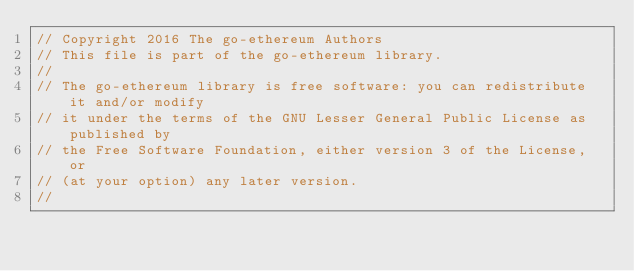Convert code to text. <code><loc_0><loc_0><loc_500><loc_500><_Go_>// Copyright 2016 The go-ethereum Authors
// This file is part of the go-ethereum library.
//
// The go-ethereum library is free software: you can redistribute it and/or modify
// it under the terms of the GNU Lesser General Public License as published by
// the Free Software Foundation, either version 3 of the License, or
// (at your option) any later version.
//</code> 